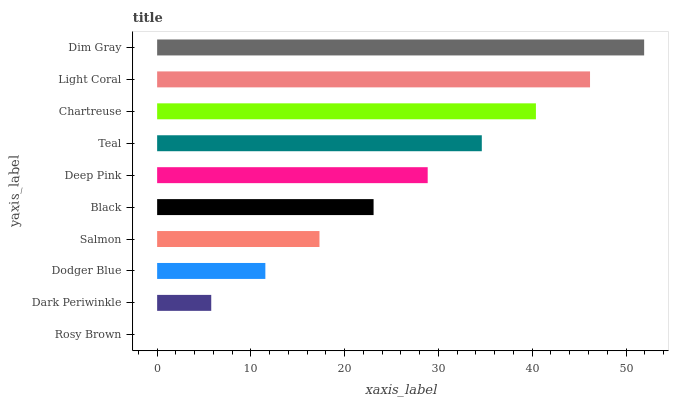Is Rosy Brown the minimum?
Answer yes or no. Yes. Is Dim Gray the maximum?
Answer yes or no. Yes. Is Dark Periwinkle the minimum?
Answer yes or no. No. Is Dark Periwinkle the maximum?
Answer yes or no. No. Is Dark Periwinkle greater than Rosy Brown?
Answer yes or no. Yes. Is Rosy Brown less than Dark Periwinkle?
Answer yes or no. Yes. Is Rosy Brown greater than Dark Periwinkle?
Answer yes or no. No. Is Dark Periwinkle less than Rosy Brown?
Answer yes or no. No. Is Deep Pink the high median?
Answer yes or no. Yes. Is Black the low median?
Answer yes or no. Yes. Is Black the high median?
Answer yes or no. No. Is Dodger Blue the low median?
Answer yes or no. No. 